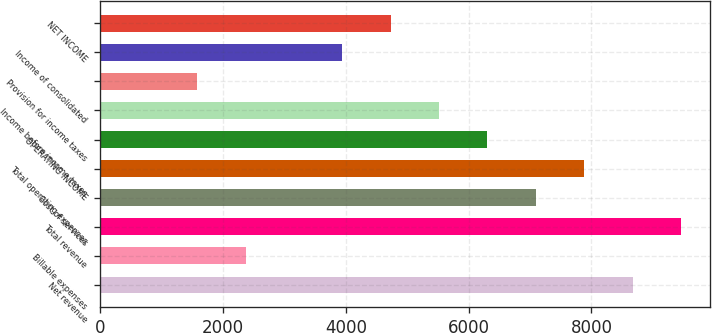Convert chart. <chart><loc_0><loc_0><loc_500><loc_500><bar_chart><fcel>Net revenue<fcel>Billable expenses<fcel>Total revenue<fcel>Cost of services<fcel>Total operating expenses<fcel>OPERATING INCOME<fcel>Income before income taxes<fcel>Provision for income taxes<fcel>Income of consolidated<fcel>NET INCOME<nl><fcel>8670.45<fcel>2365.73<fcel>9458.54<fcel>7094.27<fcel>7882.36<fcel>6306.18<fcel>5518.09<fcel>1577.64<fcel>3941.91<fcel>4730<nl></chart> 